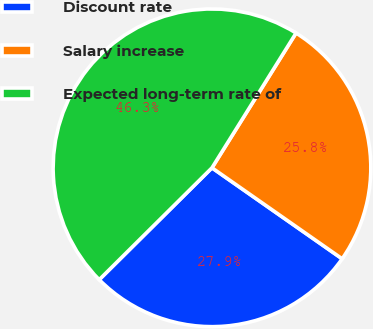Convert chart to OTSL. <chart><loc_0><loc_0><loc_500><loc_500><pie_chart><fcel>Discount rate<fcel>Salary increase<fcel>Expected long-term rate of<nl><fcel>27.85%<fcel>25.83%<fcel>46.31%<nl></chart> 